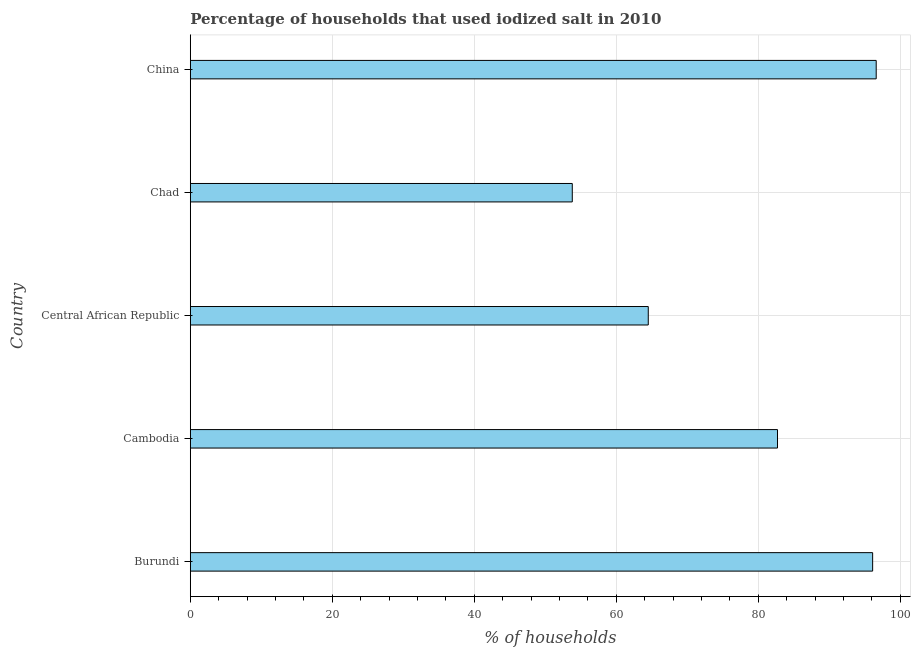What is the title of the graph?
Your answer should be compact. Percentage of households that used iodized salt in 2010. What is the label or title of the X-axis?
Your answer should be very brief. % of households. What is the label or title of the Y-axis?
Your answer should be compact. Country. What is the percentage of households where iodized salt is consumed in Cambodia?
Give a very brief answer. 82.7. Across all countries, what is the maximum percentage of households where iodized salt is consumed?
Offer a very short reply. 96.6. Across all countries, what is the minimum percentage of households where iodized salt is consumed?
Offer a very short reply. 53.8. In which country was the percentage of households where iodized salt is consumed minimum?
Give a very brief answer. Chad. What is the sum of the percentage of households where iodized salt is consumed?
Offer a terse response. 393.7. What is the difference between the percentage of households where iodized salt is consumed in Cambodia and China?
Offer a terse response. -13.9. What is the average percentage of households where iodized salt is consumed per country?
Your answer should be very brief. 78.74. What is the median percentage of households where iodized salt is consumed?
Your answer should be very brief. 82.7. In how many countries, is the percentage of households where iodized salt is consumed greater than 60 %?
Your answer should be compact. 4. What is the ratio of the percentage of households where iodized salt is consumed in Burundi to that in Chad?
Offer a very short reply. 1.79. Is the difference between the percentage of households where iodized salt is consumed in Chad and China greater than the difference between any two countries?
Your response must be concise. Yes. Is the sum of the percentage of households where iodized salt is consumed in Cambodia and Chad greater than the maximum percentage of households where iodized salt is consumed across all countries?
Ensure brevity in your answer.  Yes. What is the difference between the highest and the lowest percentage of households where iodized salt is consumed?
Your answer should be very brief. 42.8. Are all the bars in the graph horizontal?
Offer a very short reply. Yes. How many countries are there in the graph?
Offer a terse response. 5. What is the % of households in Burundi?
Offer a very short reply. 96.1. What is the % of households in Cambodia?
Give a very brief answer. 82.7. What is the % of households of Central African Republic?
Give a very brief answer. 64.5. What is the % of households in Chad?
Your answer should be very brief. 53.8. What is the % of households in China?
Make the answer very short. 96.6. What is the difference between the % of households in Burundi and Central African Republic?
Ensure brevity in your answer.  31.6. What is the difference between the % of households in Burundi and Chad?
Offer a very short reply. 42.3. What is the difference between the % of households in Burundi and China?
Ensure brevity in your answer.  -0.5. What is the difference between the % of households in Cambodia and Chad?
Your response must be concise. 28.9. What is the difference between the % of households in Central African Republic and Chad?
Offer a terse response. 10.7. What is the difference between the % of households in Central African Republic and China?
Your answer should be compact. -32.1. What is the difference between the % of households in Chad and China?
Provide a short and direct response. -42.8. What is the ratio of the % of households in Burundi to that in Cambodia?
Ensure brevity in your answer.  1.16. What is the ratio of the % of households in Burundi to that in Central African Republic?
Offer a terse response. 1.49. What is the ratio of the % of households in Burundi to that in Chad?
Your answer should be compact. 1.79. What is the ratio of the % of households in Cambodia to that in Central African Republic?
Offer a very short reply. 1.28. What is the ratio of the % of households in Cambodia to that in Chad?
Offer a terse response. 1.54. What is the ratio of the % of households in Cambodia to that in China?
Make the answer very short. 0.86. What is the ratio of the % of households in Central African Republic to that in Chad?
Your answer should be compact. 1.2. What is the ratio of the % of households in Central African Republic to that in China?
Offer a very short reply. 0.67. What is the ratio of the % of households in Chad to that in China?
Keep it short and to the point. 0.56. 